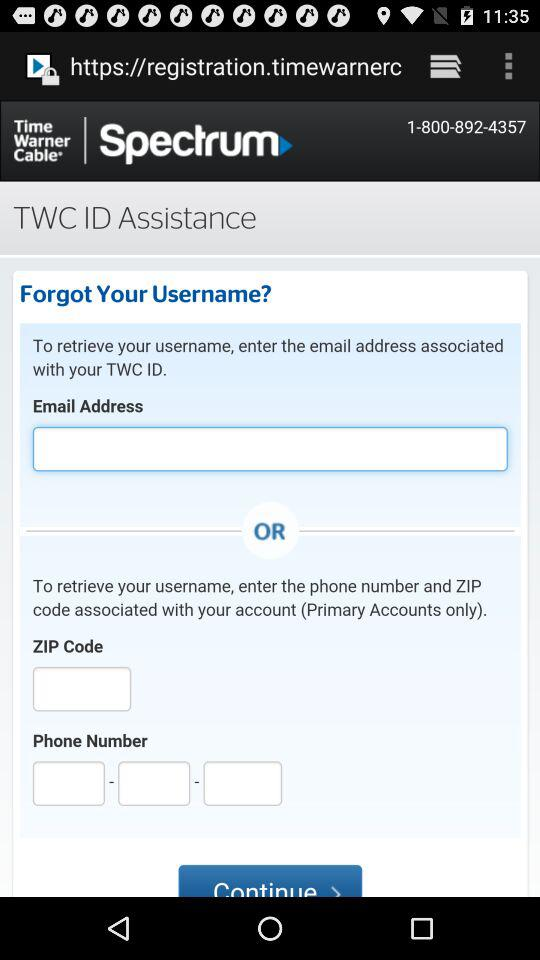What is the name of the application? The name of the application is "Spectrum". 